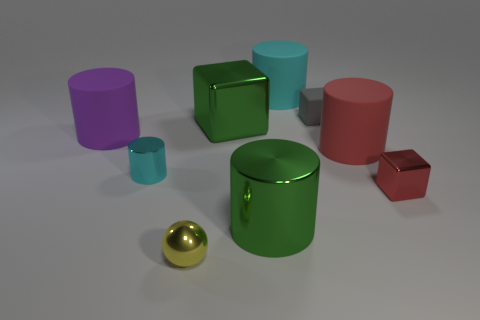Subtract all purple cylinders. How many cylinders are left? 4 Subtract all big green metallic cylinders. How many cylinders are left? 4 Subtract 1 cylinders. How many cylinders are left? 4 Subtract all yellow cylinders. Subtract all cyan balls. How many cylinders are left? 5 Add 1 red metallic objects. How many objects exist? 10 Subtract all cylinders. How many objects are left? 4 Add 5 green shiny things. How many green shiny things are left? 7 Add 1 tiny blue metal cylinders. How many tiny blue metal cylinders exist? 1 Subtract 0 blue cubes. How many objects are left? 9 Subtract all tiny gray cubes. Subtract all tiny red metallic things. How many objects are left? 7 